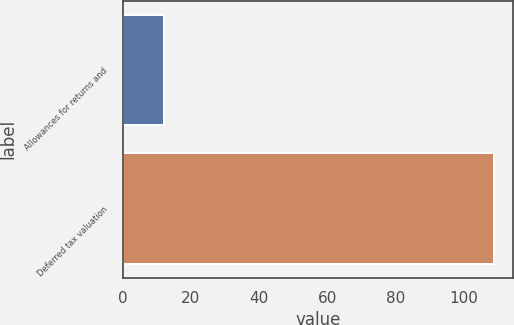Convert chart. <chart><loc_0><loc_0><loc_500><loc_500><bar_chart><fcel>Allowances for returns and<fcel>Deferred tax valuation<nl><fcel>12<fcel>109<nl></chart> 